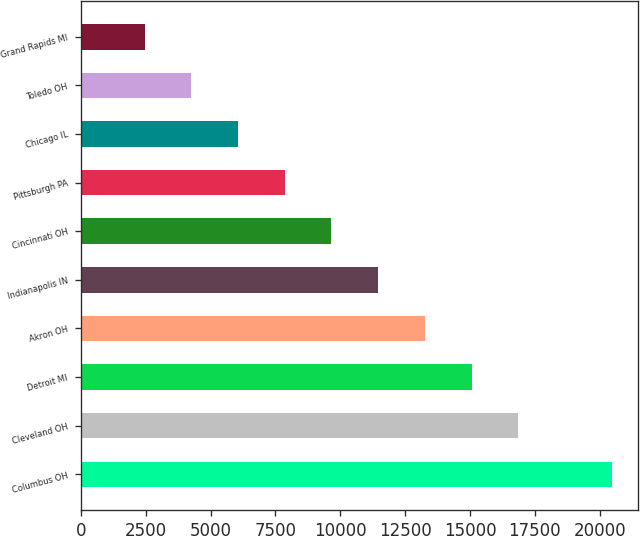Convert chart to OTSL. <chart><loc_0><loc_0><loc_500><loc_500><bar_chart><fcel>Columbus OH<fcel>Cleveland OH<fcel>Detroit MI<fcel>Akron OH<fcel>Indianapolis IN<fcel>Cincinnati OH<fcel>Pittsburgh PA<fcel>Chicago IL<fcel>Toledo OH<fcel>Grand Rapids MI<nl><fcel>20453<fcel>16855.6<fcel>15056.9<fcel>13258.2<fcel>11459.5<fcel>9660.8<fcel>7862.1<fcel>6063.4<fcel>4264.7<fcel>2466<nl></chart> 